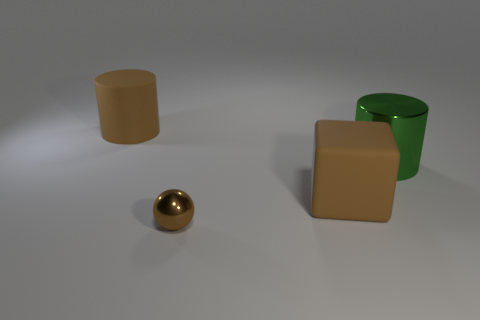Add 3 red metal objects. How many objects exist? 7 Subtract all spheres. How many objects are left? 3 Subtract all big metallic cylinders. Subtract all small objects. How many objects are left? 2 Add 4 big cylinders. How many big cylinders are left? 6 Add 4 small brown matte cylinders. How many small brown matte cylinders exist? 4 Subtract 0 yellow cylinders. How many objects are left? 4 Subtract 1 cylinders. How many cylinders are left? 1 Subtract all green spheres. Subtract all red blocks. How many spheres are left? 1 Subtract all green cylinders. How many purple spheres are left? 0 